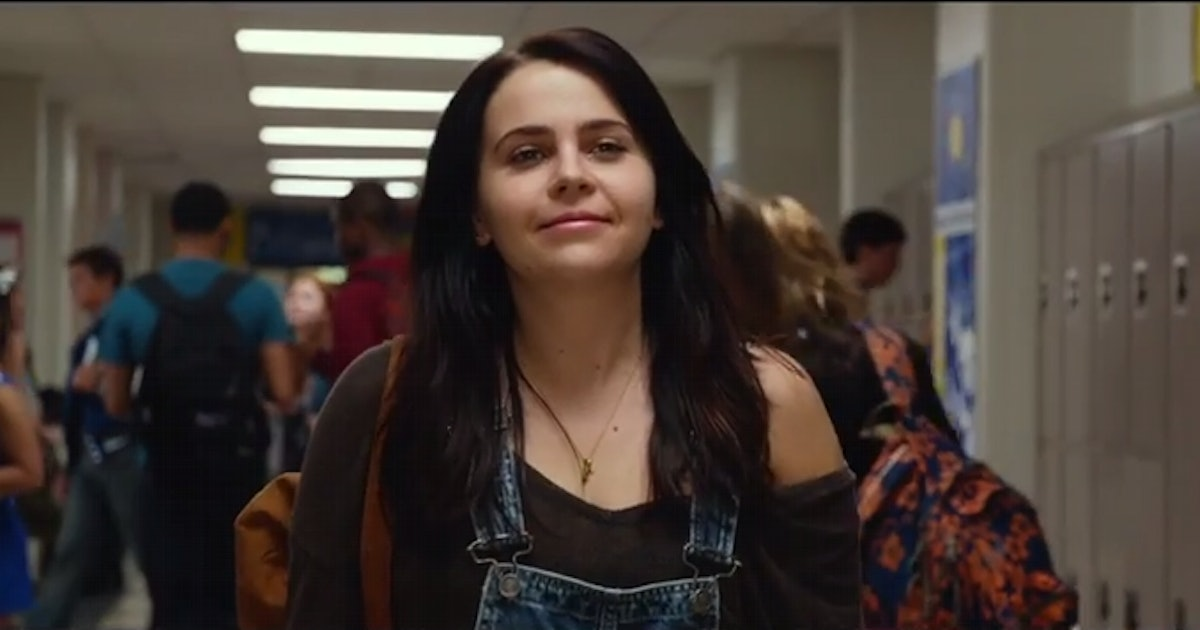Can you describe the fashion style in this image? Of course! The main character is styled in a contemporary, casual fashion that blends comfort with a touch of retro flair. Her denim overalls over a black tank top, coupled with a loose, brown cardigan, exude an effortlessly stylish vibe. The ensemble is accessorized simply with a modest necklace, making her outfit ideally suited for a casual school day. 